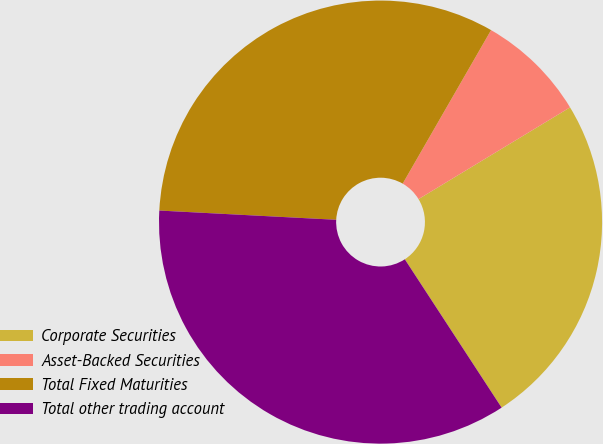<chart> <loc_0><loc_0><loc_500><loc_500><pie_chart><fcel>Corporate Securities<fcel>Asset-Backed Securities<fcel>Total Fixed Maturities<fcel>Total other trading account<nl><fcel>24.46%<fcel>8.02%<fcel>32.48%<fcel>35.03%<nl></chart> 